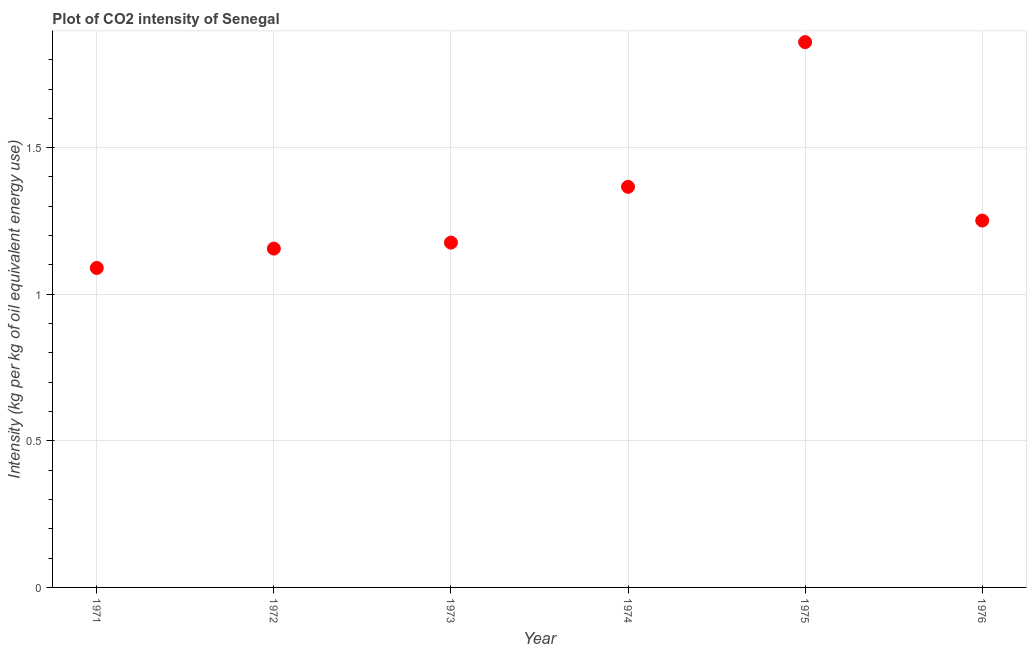What is the co2 intensity in 1975?
Your answer should be compact. 1.86. Across all years, what is the maximum co2 intensity?
Keep it short and to the point. 1.86. Across all years, what is the minimum co2 intensity?
Give a very brief answer. 1.09. In which year was the co2 intensity maximum?
Provide a short and direct response. 1975. In which year was the co2 intensity minimum?
Your answer should be very brief. 1971. What is the sum of the co2 intensity?
Offer a very short reply. 7.9. What is the difference between the co2 intensity in 1971 and 1973?
Your answer should be compact. -0.09. What is the average co2 intensity per year?
Your answer should be compact. 1.32. What is the median co2 intensity?
Ensure brevity in your answer.  1.21. In how many years, is the co2 intensity greater than 0.6 kg?
Offer a very short reply. 6. What is the ratio of the co2 intensity in 1973 to that in 1975?
Provide a short and direct response. 0.63. Is the co2 intensity in 1972 less than that in 1975?
Your answer should be very brief. Yes. Is the difference between the co2 intensity in 1971 and 1974 greater than the difference between any two years?
Your response must be concise. No. What is the difference between the highest and the second highest co2 intensity?
Give a very brief answer. 0.49. Is the sum of the co2 intensity in 1972 and 1975 greater than the maximum co2 intensity across all years?
Ensure brevity in your answer.  Yes. What is the difference between the highest and the lowest co2 intensity?
Offer a terse response. 0.77. Does the co2 intensity monotonically increase over the years?
Keep it short and to the point. No. How many years are there in the graph?
Make the answer very short. 6. Are the values on the major ticks of Y-axis written in scientific E-notation?
Provide a succinct answer. No. What is the title of the graph?
Offer a terse response. Plot of CO2 intensity of Senegal. What is the label or title of the Y-axis?
Offer a terse response. Intensity (kg per kg of oil equivalent energy use). What is the Intensity (kg per kg of oil equivalent energy use) in 1971?
Your answer should be compact. 1.09. What is the Intensity (kg per kg of oil equivalent energy use) in 1972?
Make the answer very short. 1.16. What is the Intensity (kg per kg of oil equivalent energy use) in 1973?
Give a very brief answer. 1.18. What is the Intensity (kg per kg of oil equivalent energy use) in 1974?
Ensure brevity in your answer.  1.37. What is the Intensity (kg per kg of oil equivalent energy use) in 1975?
Keep it short and to the point. 1.86. What is the Intensity (kg per kg of oil equivalent energy use) in 1976?
Your answer should be very brief. 1.25. What is the difference between the Intensity (kg per kg of oil equivalent energy use) in 1971 and 1972?
Keep it short and to the point. -0.07. What is the difference between the Intensity (kg per kg of oil equivalent energy use) in 1971 and 1973?
Ensure brevity in your answer.  -0.09. What is the difference between the Intensity (kg per kg of oil equivalent energy use) in 1971 and 1974?
Give a very brief answer. -0.28. What is the difference between the Intensity (kg per kg of oil equivalent energy use) in 1971 and 1975?
Make the answer very short. -0.77. What is the difference between the Intensity (kg per kg of oil equivalent energy use) in 1971 and 1976?
Make the answer very short. -0.16. What is the difference between the Intensity (kg per kg of oil equivalent energy use) in 1972 and 1973?
Ensure brevity in your answer.  -0.02. What is the difference between the Intensity (kg per kg of oil equivalent energy use) in 1972 and 1974?
Ensure brevity in your answer.  -0.21. What is the difference between the Intensity (kg per kg of oil equivalent energy use) in 1972 and 1975?
Keep it short and to the point. -0.7. What is the difference between the Intensity (kg per kg of oil equivalent energy use) in 1972 and 1976?
Keep it short and to the point. -0.1. What is the difference between the Intensity (kg per kg of oil equivalent energy use) in 1973 and 1974?
Provide a short and direct response. -0.19. What is the difference between the Intensity (kg per kg of oil equivalent energy use) in 1973 and 1975?
Your answer should be compact. -0.68. What is the difference between the Intensity (kg per kg of oil equivalent energy use) in 1973 and 1976?
Offer a very short reply. -0.08. What is the difference between the Intensity (kg per kg of oil equivalent energy use) in 1974 and 1975?
Offer a very short reply. -0.49. What is the difference between the Intensity (kg per kg of oil equivalent energy use) in 1974 and 1976?
Ensure brevity in your answer.  0.12. What is the difference between the Intensity (kg per kg of oil equivalent energy use) in 1975 and 1976?
Your response must be concise. 0.61. What is the ratio of the Intensity (kg per kg of oil equivalent energy use) in 1971 to that in 1972?
Keep it short and to the point. 0.94. What is the ratio of the Intensity (kg per kg of oil equivalent energy use) in 1971 to that in 1973?
Keep it short and to the point. 0.93. What is the ratio of the Intensity (kg per kg of oil equivalent energy use) in 1971 to that in 1974?
Make the answer very short. 0.8. What is the ratio of the Intensity (kg per kg of oil equivalent energy use) in 1971 to that in 1975?
Make the answer very short. 0.59. What is the ratio of the Intensity (kg per kg of oil equivalent energy use) in 1971 to that in 1976?
Offer a terse response. 0.87. What is the ratio of the Intensity (kg per kg of oil equivalent energy use) in 1972 to that in 1974?
Make the answer very short. 0.85. What is the ratio of the Intensity (kg per kg of oil equivalent energy use) in 1972 to that in 1975?
Make the answer very short. 0.62. What is the ratio of the Intensity (kg per kg of oil equivalent energy use) in 1972 to that in 1976?
Ensure brevity in your answer.  0.92. What is the ratio of the Intensity (kg per kg of oil equivalent energy use) in 1973 to that in 1974?
Your answer should be very brief. 0.86. What is the ratio of the Intensity (kg per kg of oil equivalent energy use) in 1973 to that in 1975?
Provide a succinct answer. 0.63. What is the ratio of the Intensity (kg per kg of oil equivalent energy use) in 1973 to that in 1976?
Provide a short and direct response. 0.94. What is the ratio of the Intensity (kg per kg of oil equivalent energy use) in 1974 to that in 1975?
Provide a succinct answer. 0.73. What is the ratio of the Intensity (kg per kg of oil equivalent energy use) in 1974 to that in 1976?
Provide a short and direct response. 1.09. What is the ratio of the Intensity (kg per kg of oil equivalent energy use) in 1975 to that in 1976?
Your answer should be compact. 1.49. 